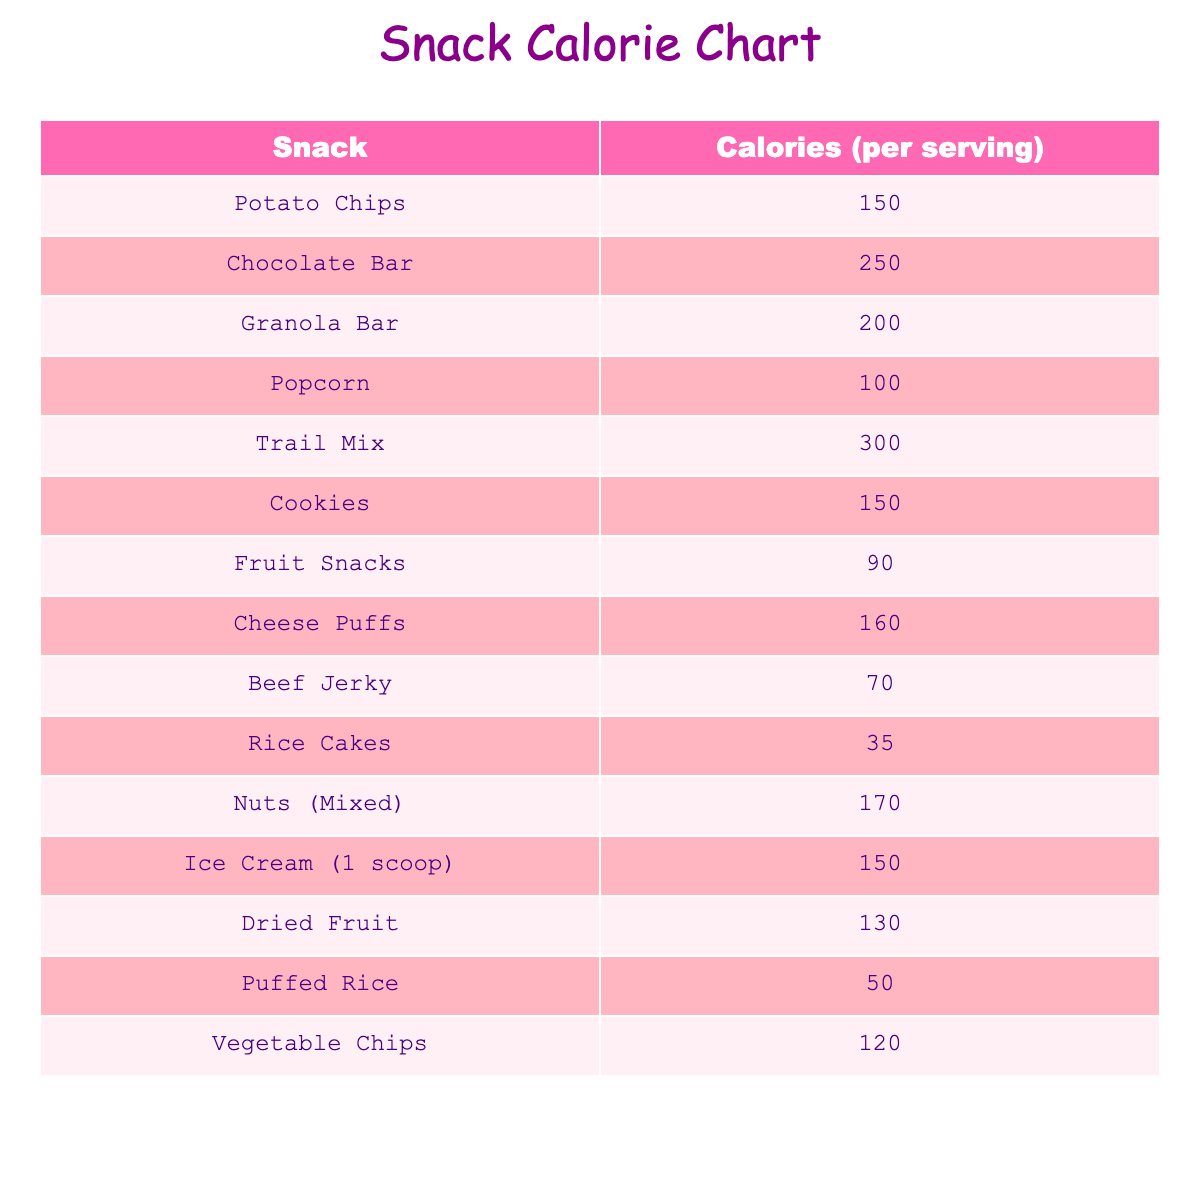What is the caloric value of a Chocolate Bar? The table shows that a Chocolate Bar has a caloric value of 250 per serving.
Answer: 250 Which snack has the lowest caloric value? Looking through the table, the lowest caloric value is for Rice Cakes, which has 35 calories.
Answer: 35 Is the caloric value of Popcorn higher than that of Vegetable Chips? The table shows Popcorn has 100 calories and Vegetable Chips has 120 calories, so Popcorn has a lower caloric value.
Answer: No What is the sum of the calories in Trail Mix and Granola Bar? Trail Mix has 300 calories, and Granola Bar has 200 calories. Adding them together gives 300 + 200 = 500 calories.
Answer: 500 How many snacks have a caloric value of 150 or more? By examining the table, the snacks that meet this criterion are Chocolate Bar, Granola Bar, Trail Mix, Cookies, Ice Cream, and Cheese Puffs. That totals to 6 snacks.
Answer: 6 What is the average caloric value of the snacks listed in the table? The total sum of all the caloric values is 150 + 250 + 200 + 100 + 300 + 150 + 90 + 160 + 70 + 35 + 170 + 150 + 130 + 50 + 120 = 1,855. Divided by the number of snacks, which is 15, gives an average of 1,855 / 15 = 123.67.
Answer: 123.67 Do Fruit Snacks have fewer calories than Beef Jerky? Fruit Snacks have 90 calories, and Beef Jerky has 70 calories. Since 90 > 70, this statement is incorrect.
Answer: No Which snack has more calories, Nuts or Cookies? Nuts have 170 calories and Cookies have 150 calories. Since 170 > 150, Nuts have more calories.
Answer: Nuts How many snacks have a caloric value of less than 100? In the table, only Beef Jerky, Puffed Rice, and Fruit Snacks fall under 100 calories, which totals to 3 snacks.
Answer: 3 Which is more caloric, a serving of Ice Cream or a serving of Cheese Puffs? Ice Cream has 150 calories while Cheese Puffs have 160 calories. This means Cheese Puffs are more caloric.
Answer: Cheese Puffs 